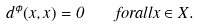Convert formula to latex. <formula><loc_0><loc_0><loc_500><loc_500>d ^ { \phi } ( x , x ) = 0 \quad f o r a l l x \in X .</formula> 